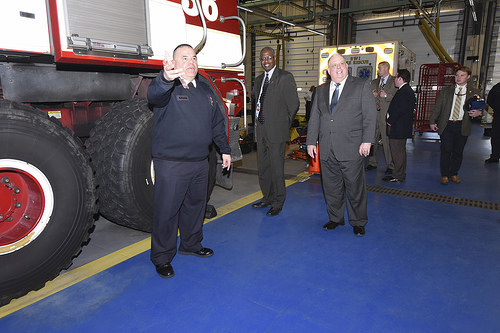<image>
Is the man in the truck? No. The man is not contained within the truck. These objects have a different spatial relationship. 